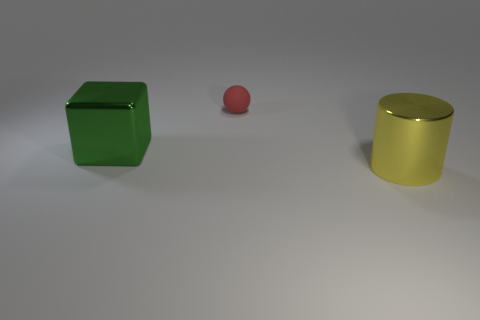How would you describe the arrangement of the objects? The objects are arranged in a line with even spacing on a flat surface. From left to right, there's a green cube, a pink sphere, and a gold cylinder. Their positions create a sense of balance and order, with the sphere centered between the two other objects. 